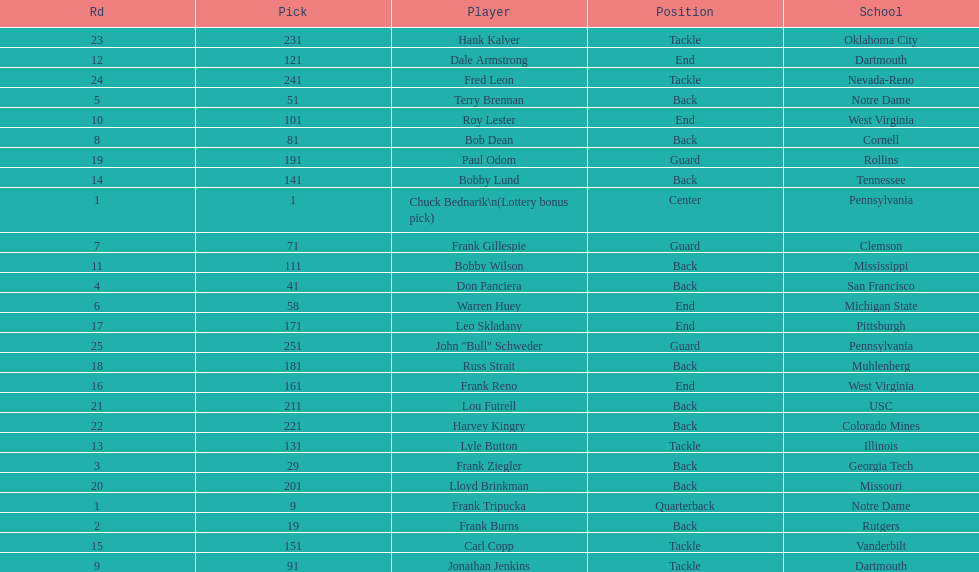What was the position that most of the players had? Back. 